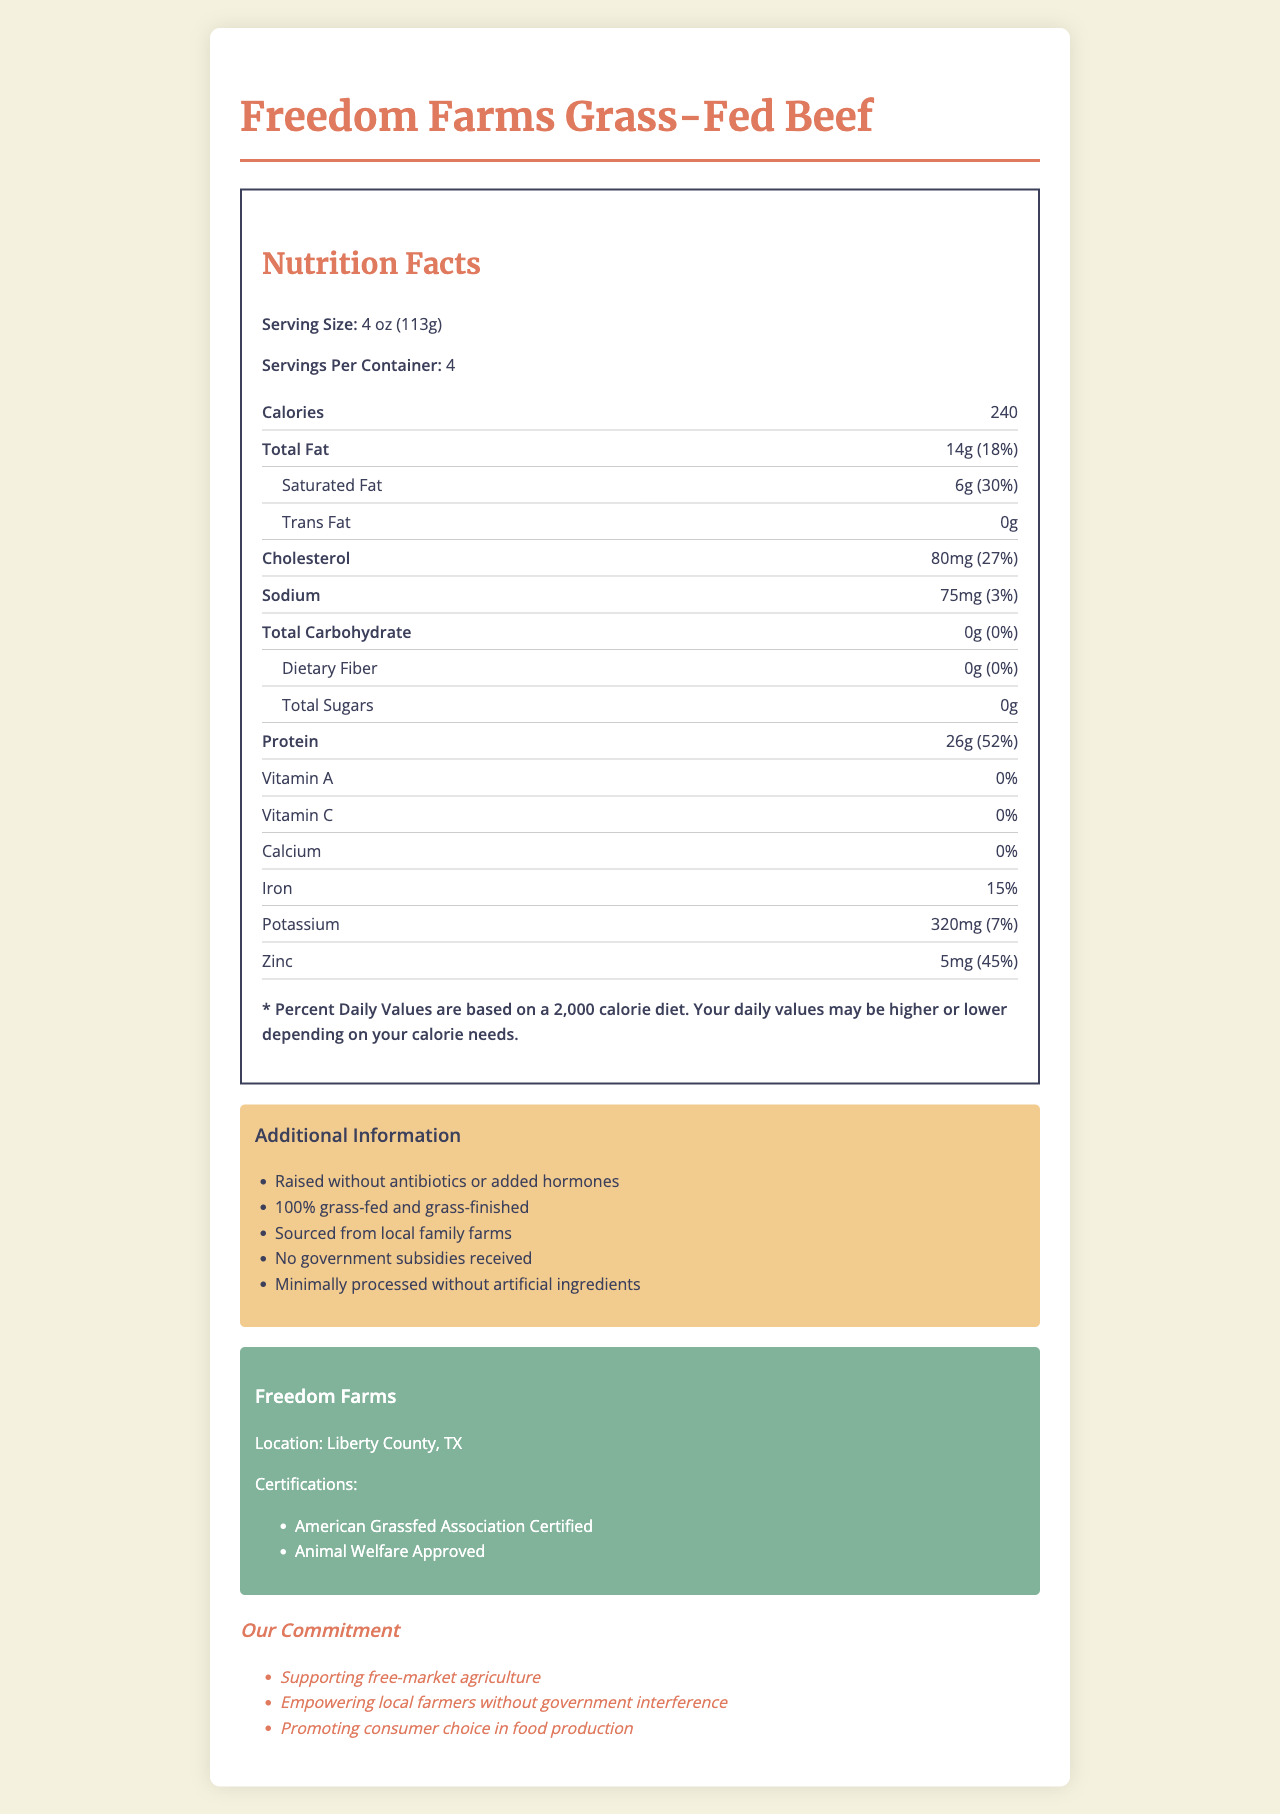what is the serving size of Freedom Farms Grass-Fed Beef? The serving size is listed near the top of the Nutrition Facts section as "Serving Size: 4 oz (113g)."
Answer: 4 oz (113g) how many calories are there per serving? The calorie content per serving is stated in the Nutrition Facts section as "Calories: 240."
Answer: 240 what percentage of daily value for saturated fat does one serving provide? The percentage of daily value for saturated fat is specified as "Saturated Fat: 6g (30%)."
Answer: 30% does this product contain any Vitamin A? The nutrition facts list Vitamin A with a value of "0%," indicating it does not provide any Vitamin A.
Answer: No how much protein is in one serving of this beef? The document lists the protein content per serving as "Protein: 26g."
Answer: 26g which certification is not mentioned for Freedom Farms? A. Organic Certified B. American Grassfed Association Certified C. Animal Welfare Approved The document mentions "American Grassfed Association Certified" and "Animal Welfare Approved" but does not list "Organic Certified."
Answer: A. Organic Certified what is the total amount of cholesterol in a serving? The Nutrition Facts section lists cholesterol at "80mg (27%)."
Answer: 80mg has this product been raised with antibiotics or added hormones? The additional information section clearly states "Raised without antibiotics or added hormones."
Answer: No what is the total carbohydrate content in one serving? The document specifies "Total Carbohydrate: 0g (0%)."
Answer: 0g how much zinc does one serving of this product provide? The nutrition facts indicate that one serving provides "Zinc: 5mg (45%)."
Answer: 5mg is this beef product sourced from local family farms? Under additional information, it states "Sourced from local family farms."
Answer: Yes what is the name of the farm that produces this beef? The farm information section identifies the producer as "Freedom Farms."
Answer: Freedom Farms what percentage of daily value for sodium is in one serving? The amount of sodium per serving is listed as "75mg (3%)."
Answer: 3% which claim is made about consumer choice in the document? A. Limiting consumer choice B. Promoting consumer choice C. Restricting consumer choice The marketing claims section states, "Promoting consumer choice in food production."
Answer: B. Promoting consumer choice what is the location of Freedom Farms? The farm information section specifies the location as "Liberty County, TX."
Answer: Liberty County, TX are there any government subsidies used in the production of this beef? The additional information section clearly states, "No government subsidies received."
Answer: No summarize the main points of the document. The document provides detailed nutritional information for Freedom Farms Grass-Fed Beef, highlights the absence of antibiotics, hormones, and government subsidies, and promotes supporting local, family-run farming operations committed to free-market principles.
Answer: The document outlines the nutrition facts of Freedom Farms Grass-Fed Beef, emphasizing its natural and minimal government-influenced production methods. The product is locally sourced, raised without antibiotics or hormones, and supports free-market agriculture and local farmers. Nutritional information and farm certifications are provided. how many total servings are in one container? The document states "Servings Per Container: 4."
Answer: 4 what is the website for Freedom Farms? The document does not provide a website for Freedom Farms, so there's not enough information to answer this question.
Answer: Not enough information 